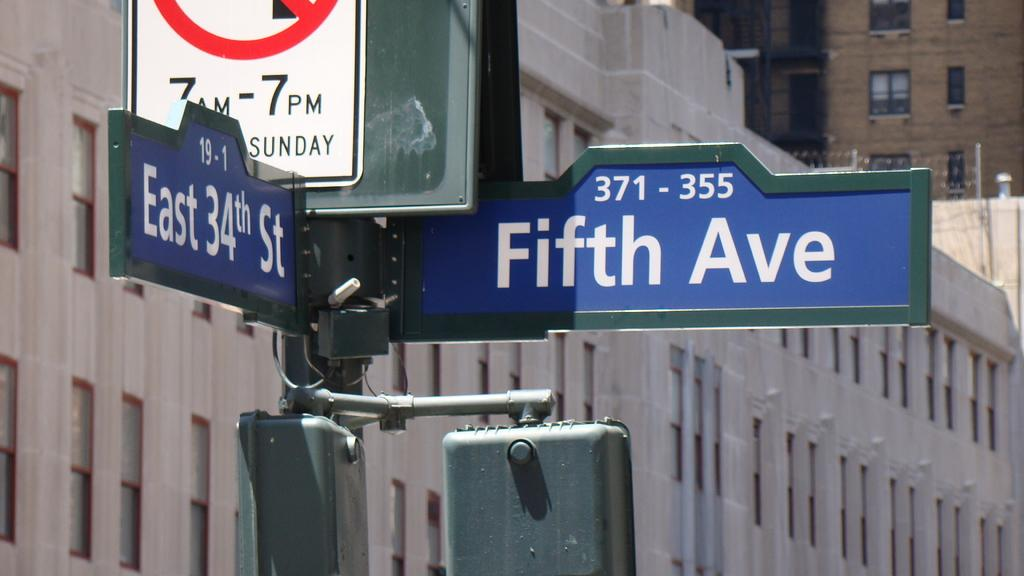<image>
Describe the image concisely. A Fifth Ave sign is blue and has the label 371-355 on it. 